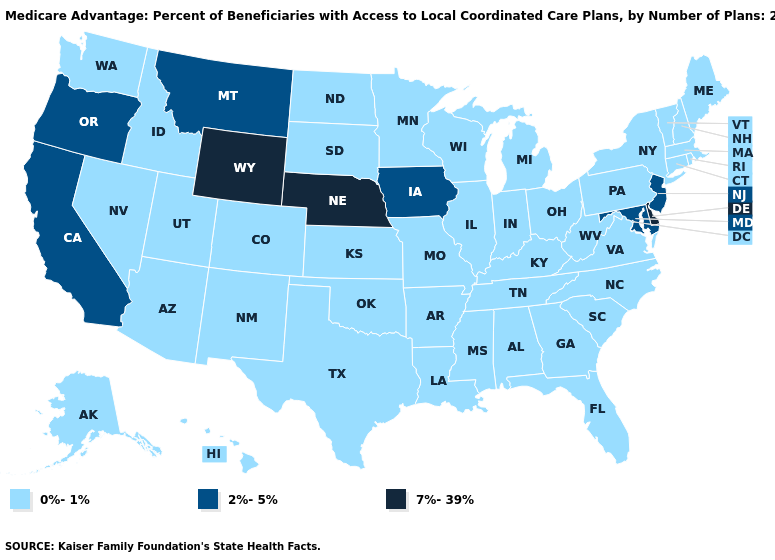What is the highest value in the USA?
Give a very brief answer. 7%-39%. What is the value of Kansas?
Answer briefly. 0%-1%. What is the lowest value in states that border Connecticut?
Concise answer only. 0%-1%. Does Pennsylvania have the highest value in the Northeast?
Short answer required. No. Does the first symbol in the legend represent the smallest category?
Be succinct. Yes. What is the lowest value in the West?
Write a very short answer. 0%-1%. Name the states that have a value in the range 7%-39%?
Give a very brief answer. Delaware, Nebraska, Wyoming. Among the states that border North Dakota , which have the lowest value?
Be succinct. Minnesota, South Dakota. Does Nevada have the highest value in the USA?
Write a very short answer. No. Does Kentucky have the highest value in the USA?
Answer briefly. No. Among the states that border Massachusetts , which have the highest value?
Short answer required. Connecticut, New Hampshire, New York, Rhode Island, Vermont. Name the states that have a value in the range 7%-39%?
Write a very short answer. Delaware, Nebraska, Wyoming. What is the value of Tennessee?
Write a very short answer. 0%-1%. What is the value of California?
Give a very brief answer. 2%-5%. What is the value of Kansas?
Short answer required. 0%-1%. 